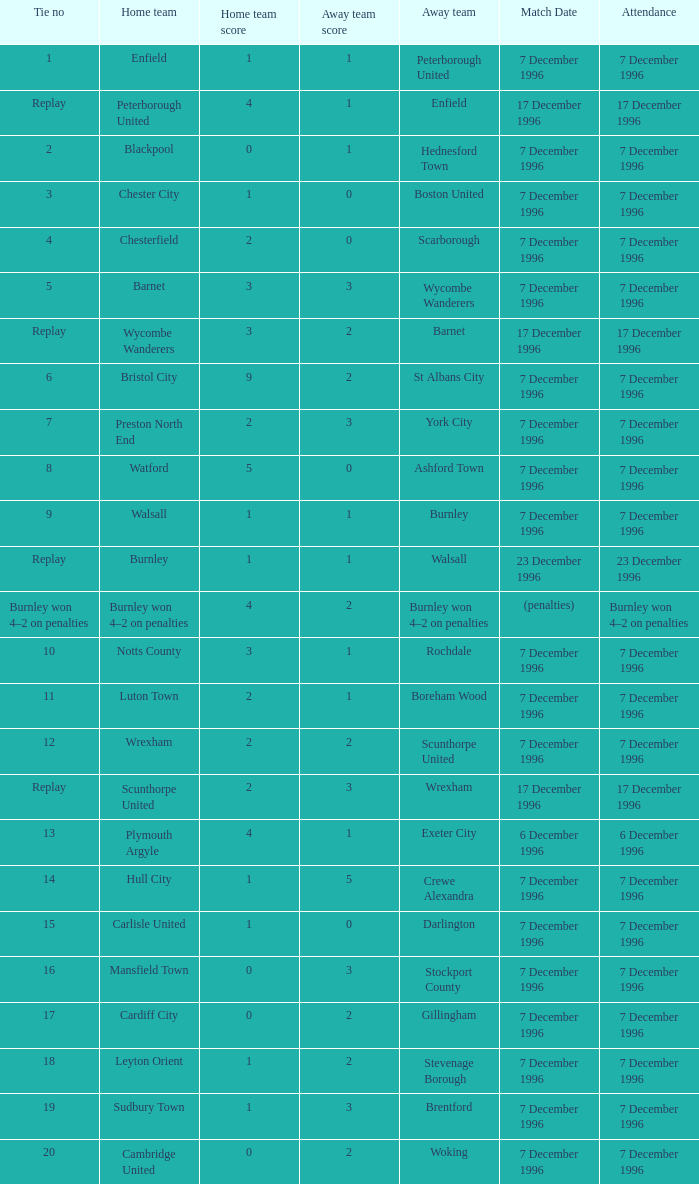What was the attendance for the home team of Walsall? 7 December 1996. 